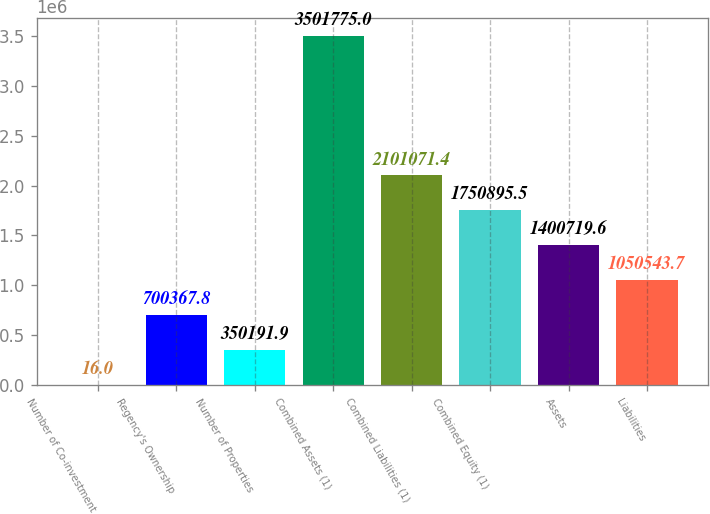<chart> <loc_0><loc_0><loc_500><loc_500><bar_chart><fcel>Number of Co-investment<fcel>Regency's Ownership<fcel>Number of Properties<fcel>Combined Assets (1)<fcel>Combined Liabilities (1)<fcel>Combined Equity (1)<fcel>Assets<fcel>Liabilities<nl><fcel>16<fcel>700368<fcel>350192<fcel>3.50178e+06<fcel>2.10107e+06<fcel>1.7509e+06<fcel>1.40072e+06<fcel>1.05054e+06<nl></chart> 